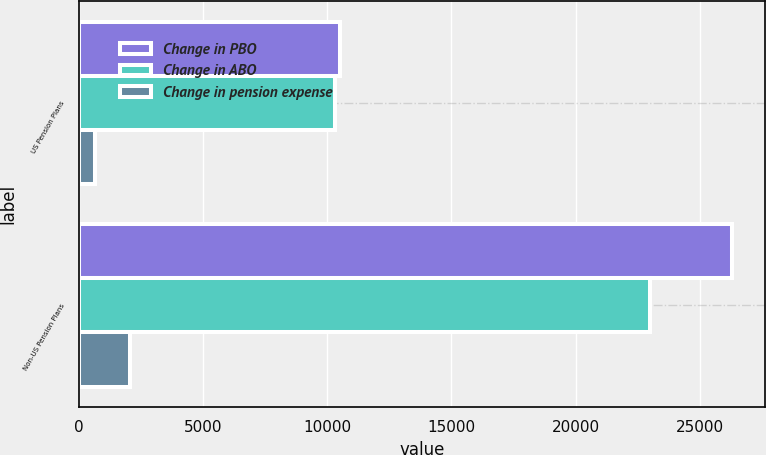Convert chart. <chart><loc_0><loc_0><loc_500><loc_500><stacked_bar_chart><ecel><fcel>US Pension Plans<fcel>Non-US Pension Plans<nl><fcel>Change in PBO<fcel>10523<fcel>26309<nl><fcel>Change in ABO<fcel>10302<fcel>22996<nl><fcel>Change in pension expense<fcel>657<fcel>2077<nl></chart> 